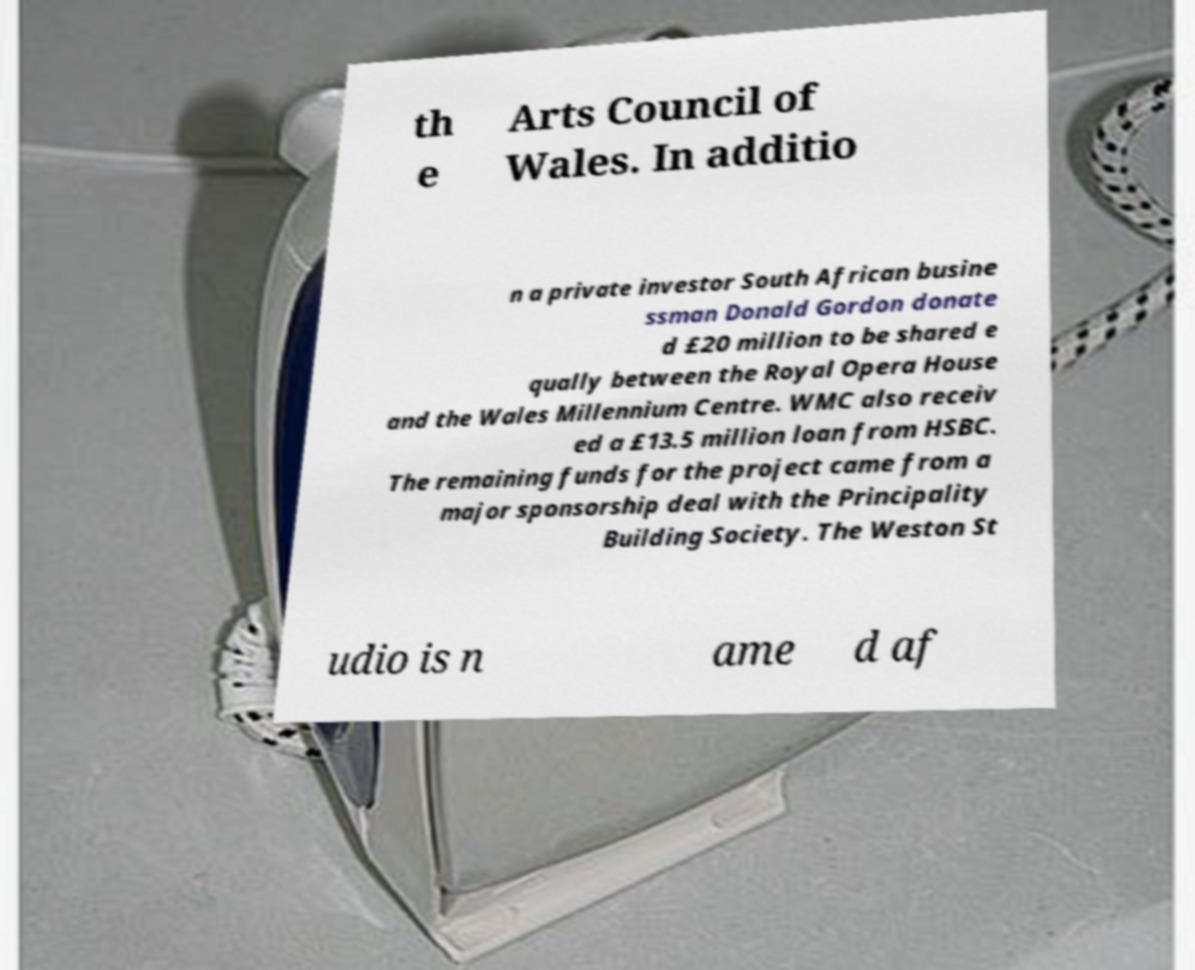There's text embedded in this image that I need extracted. Can you transcribe it verbatim? th e Arts Council of Wales. In additio n a private investor South African busine ssman Donald Gordon donate d £20 million to be shared e qually between the Royal Opera House and the Wales Millennium Centre. WMC also receiv ed a £13.5 million loan from HSBC. The remaining funds for the project came from a major sponsorship deal with the Principality Building Society. The Weston St udio is n ame d af 